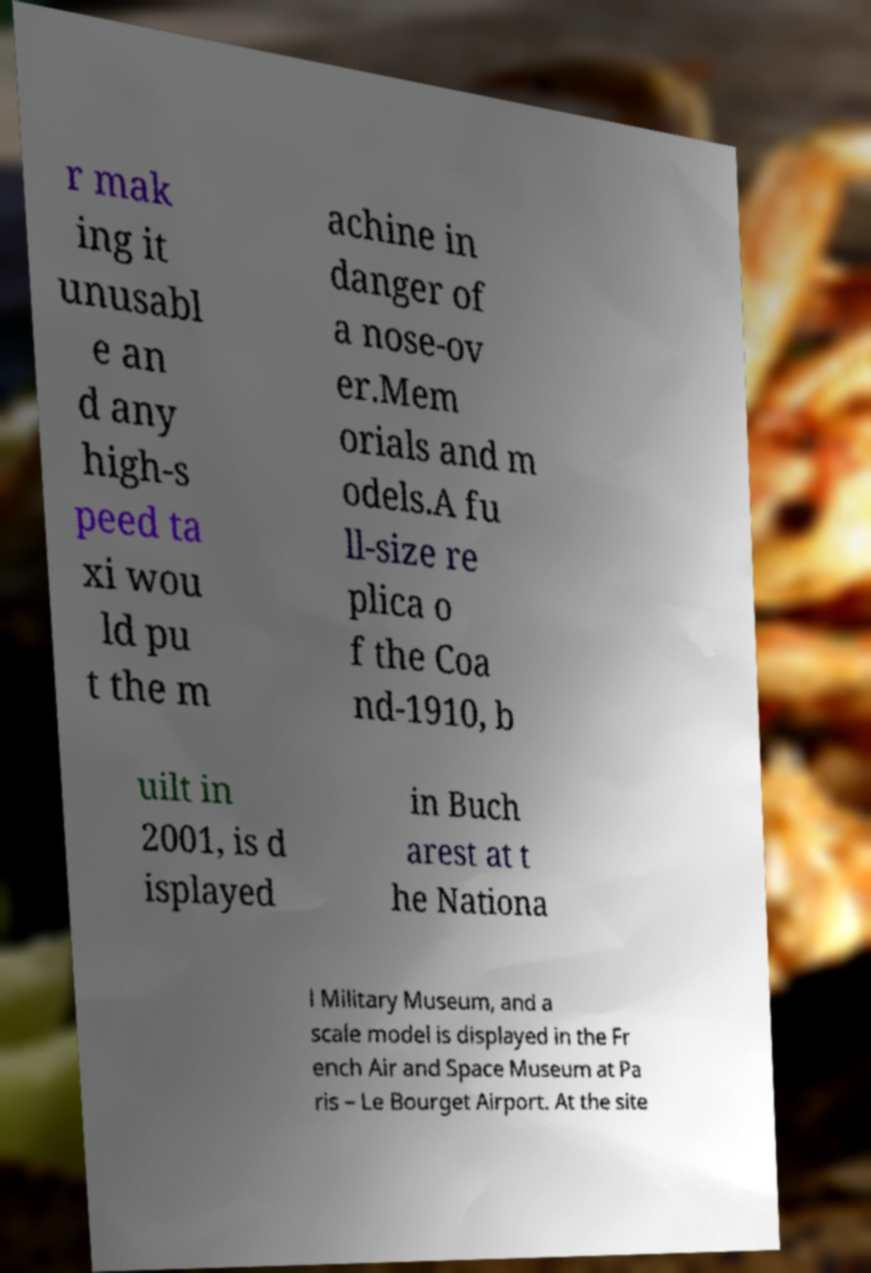Can you read and provide the text displayed in the image?This photo seems to have some interesting text. Can you extract and type it out for me? r mak ing it unusabl e an d any high-s peed ta xi wou ld pu t the m achine in danger of a nose-ov er.Mem orials and m odels.A fu ll-size re plica o f the Coa nd-1910, b uilt in 2001, is d isplayed in Buch arest at t he Nationa l Military Museum, and a scale model is displayed in the Fr ench Air and Space Museum at Pa ris – Le Bourget Airport. At the site 